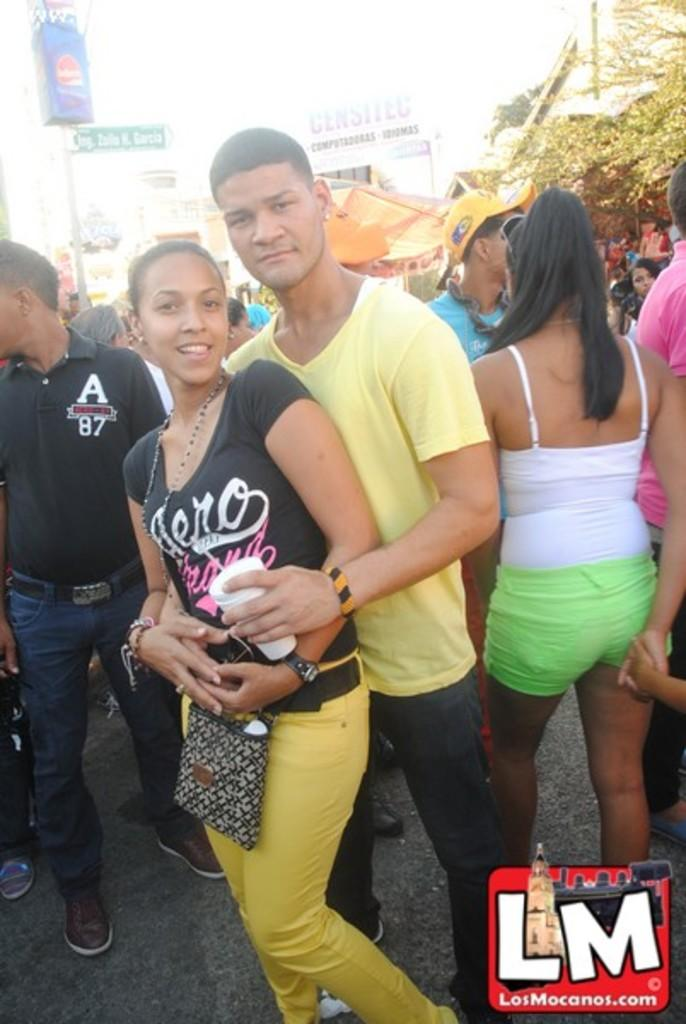What is happening between the man and the woman in the image? The man is holding the woman in the image. Can you describe the background of the image? The background is blurred, and there are people, boards, and a tree visible. How many people are in the background of the image? There are people in the background of the image, but the exact number is not specified. What is the watermark in the image? There is a watermark in the bottom right corner of the image. What type of food is being prepared by the waves in the image? There are no waves or food present in the image. What is the source of power for the people in the background of the image? The image does not provide information about the source of power for the people in the background. 